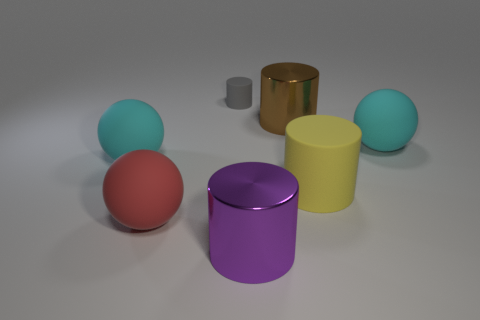Add 3 red things. How many objects exist? 10 Subtract all big red spheres. How many spheres are left? 2 Subtract 1 purple cylinders. How many objects are left? 6 Subtract all balls. How many objects are left? 4 Subtract 1 cylinders. How many cylinders are left? 3 Subtract all cyan spheres. Subtract all cyan cylinders. How many spheres are left? 1 Subtract all purple blocks. How many cyan spheres are left? 2 Subtract all large cyan balls. Subtract all large red things. How many objects are left? 4 Add 6 large purple cylinders. How many large purple cylinders are left? 7 Add 4 tiny matte cylinders. How many tiny matte cylinders exist? 5 